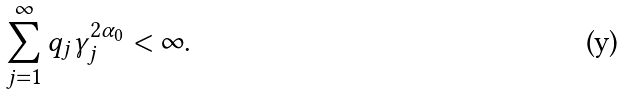Convert formula to latex. <formula><loc_0><loc_0><loc_500><loc_500>\sum _ { j = 1 } ^ { \infty } q _ { j } \gamma _ { j } ^ { 2 \alpha _ { 0 } } < \infty .</formula> 